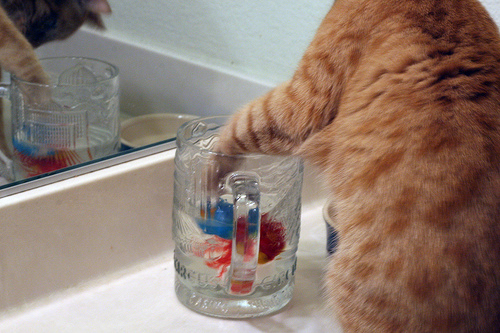<image>
Is the cat behind the glass cup? No. The cat is not behind the glass cup. From this viewpoint, the cat appears to be positioned elsewhere in the scene. Where is the paw in relation to the mirror? Is it behind the mirror? No. The paw is not behind the mirror. From this viewpoint, the paw appears to be positioned elsewhere in the scene. Is the paw in the mug? Yes. The paw is contained within or inside the mug, showing a containment relationship. Is the cat above the water cup? Yes. The cat is positioned above the water cup in the vertical space, higher up in the scene. 